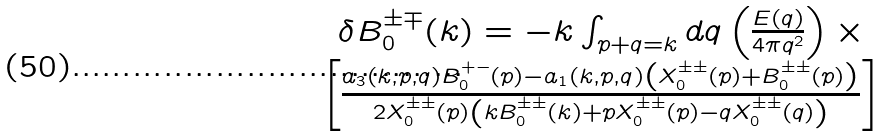Convert formula to latex. <formula><loc_0><loc_0><loc_500><loc_500>\begin{array} { c } \delta B _ { 0 } ^ { \pm \mp } ( k ) = - k \int _ { p + q = k } d { q } \left ( \frac { E ( q ) } { 4 \pi q ^ { 2 } } \right ) \times \\ \left [ \frac { a _ { 3 } ( k , p , q ) B _ { 0 } ^ { + - } ( p ) - a _ { 1 } ( k , p , q ) \left ( X _ { 0 } ^ { \pm \pm } ( p ) + B _ { 0 } ^ { \pm \pm } ( p ) \right ) } { 2 X _ { 0 } ^ { \pm \pm } ( p ) \left ( k B _ { 0 } ^ { \pm \pm } ( k ) + p X _ { 0 } ^ { \pm \pm } ( p ) - q X _ { 0 } ^ { \pm \pm } ( q ) \right ) } \right ] \end{array}</formula> 